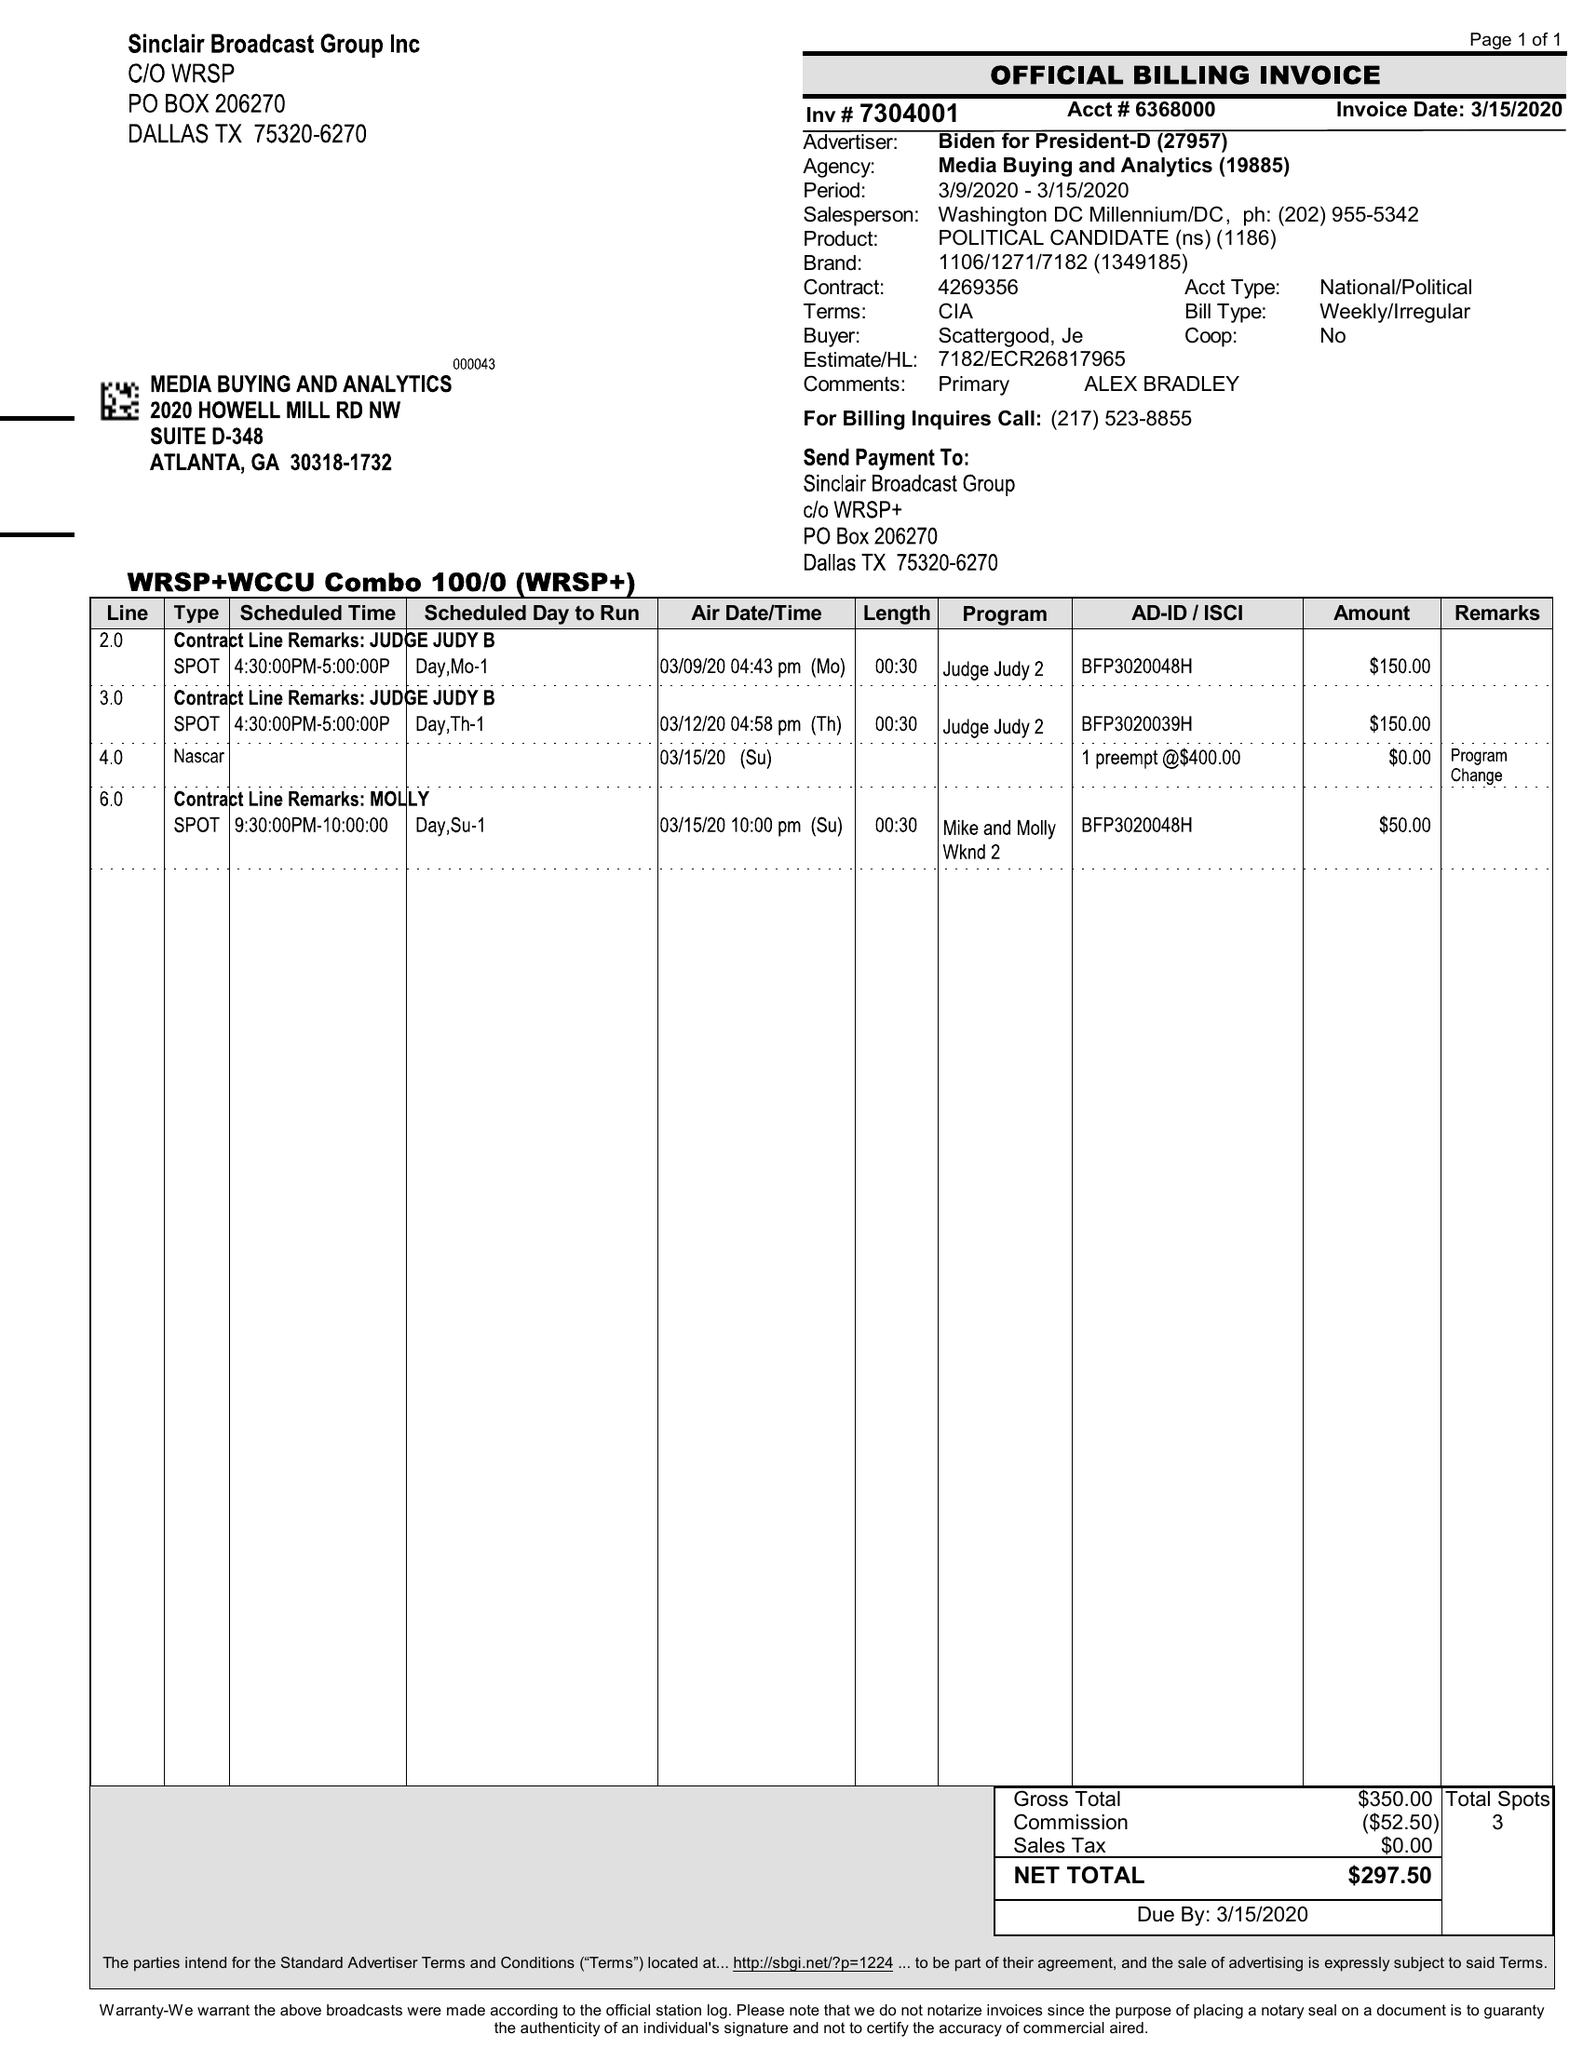What is the value for the gross_amount?
Answer the question using a single word or phrase. 350.00 